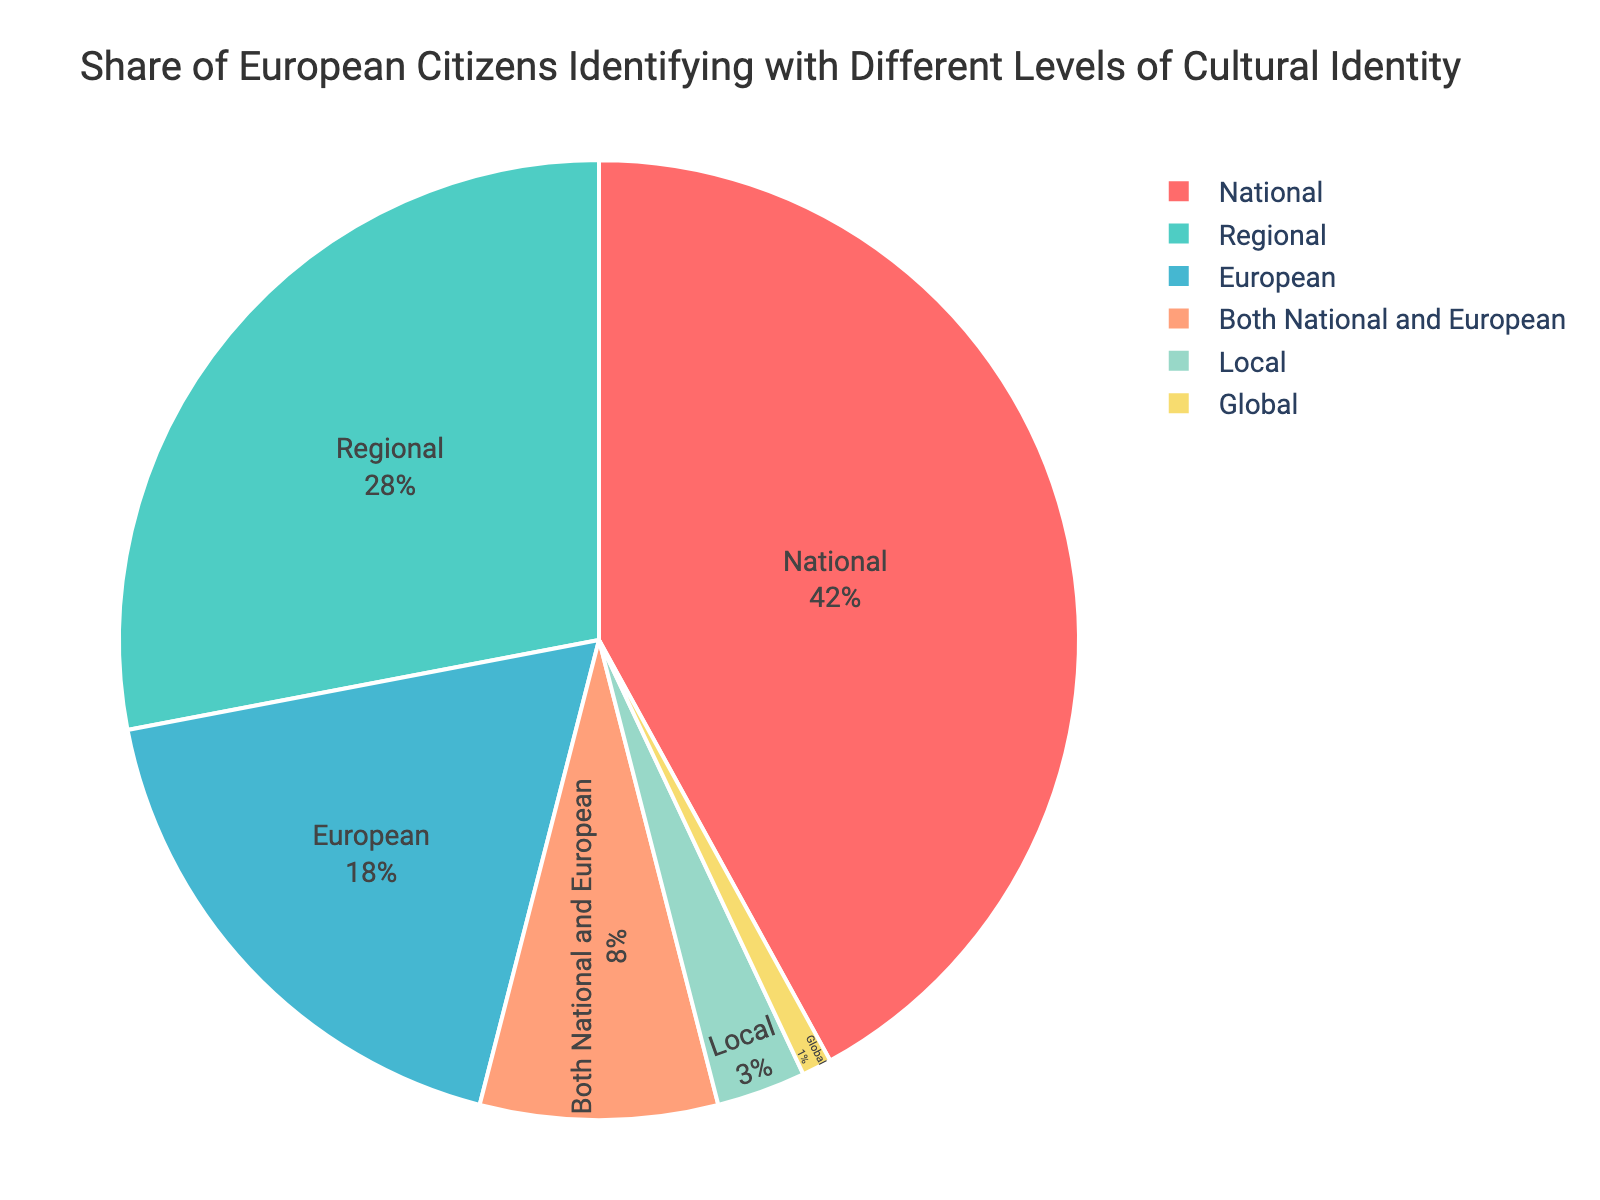Which identity level has the highest percentage of European citizens? The pie chart shows that the largest section corresponds to those identifying primarily at the national level.
Answer: National What percentage of European citizens identify as both national and European? The slice labeled "Both National and European" represents 8% of the total according to the pie chart.
Answer: 8% How does the percentage of citizens identifying regionally compare with those identifying nationally? The pie chart shows 42% of citizens identify nationally, whereas 28% identify regionally.
Answer: National identity is 14% higher than regional Combine the percentages of those identifying both nationally and European and those identifying locally. What is the sum? According to the pie chart, the percentage for "Both National and European" is 8% and for "Local" is 3%. Summing these gives 8% + 3%.
Answer: 11% Which identity levels have a smaller percentage than those identifying as European? The pie chart shows 18% identify as European. Both "Both National and European" (8%), "Local" (3%), and "Global" (1%) categories have smaller percentages.
Answer: Both National and European, Local, Global Is the percentage of citizens identifying globally more than those identifying locally? The pie chart shows 3% of citizens identify locally and 1% identify globally, so local is more.
Answer: No Compare the sum of percentages of local and global identities with regional identity. Is it greater or less? Local is 3% and global is 1%, summing them gives 4%. Regional identity is 28%, so 4% is less than 28%.
Answer: Less What color represents the regional identity level in the pie chart? According to the pie chart, the regional identity section is shown in a greenish color.
Answer: Green (mint green tone) By how much do the percentages of citizens identifying locally and globally differ? The pie chart shows the local identity at 3% and global at 1%. The difference is 3% - 1%.
Answer: 2% Which slice on the pie chart is the smallest in area? The "Global" identity level has the smallest percentage at 1%, making it the smallest slice visually.
Answer: Global 